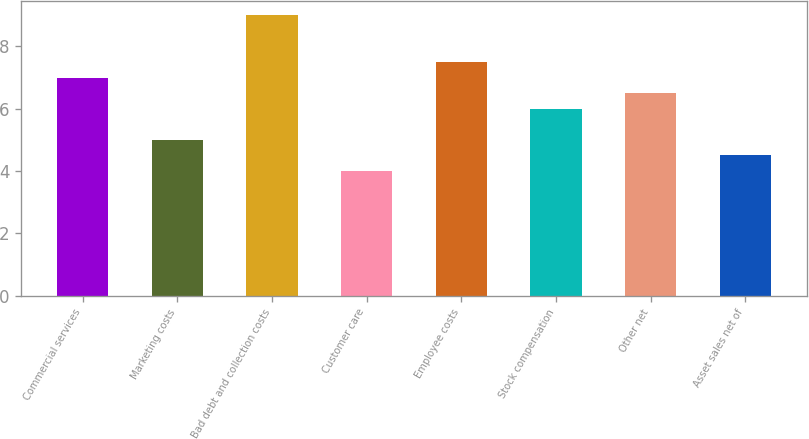<chart> <loc_0><loc_0><loc_500><loc_500><bar_chart><fcel>Commercial services<fcel>Marketing costs<fcel>Bad debt and collection costs<fcel>Customer care<fcel>Employee costs<fcel>Stock compensation<fcel>Other net<fcel>Asset sales net of<nl><fcel>7<fcel>5<fcel>9<fcel>4<fcel>7.5<fcel>6<fcel>6.5<fcel>4.5<nl></chart> 